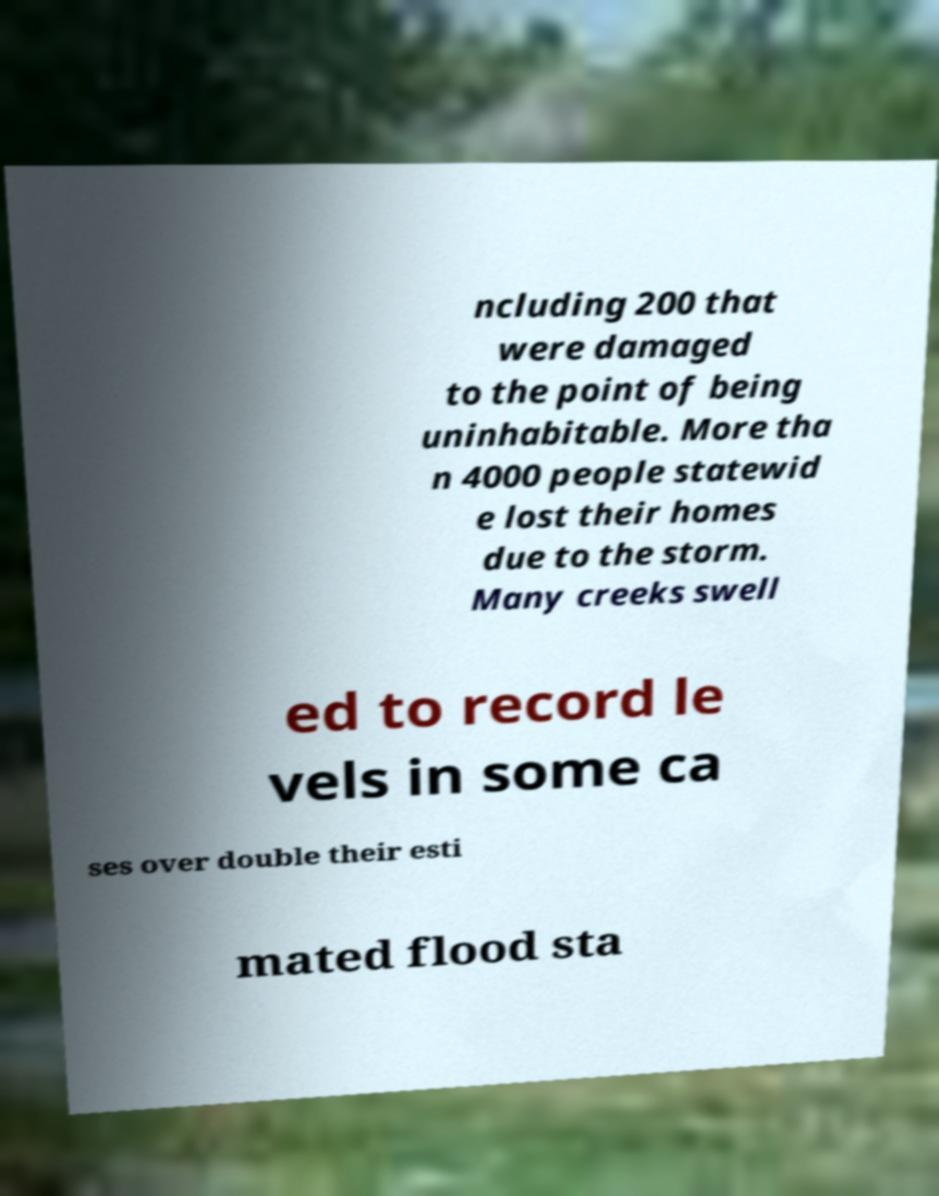For documentation purposes, I need the text within this image transcribed. Could you provide that? ncluding 200 that were damaged to the point of being uninhabitable. More tha n 4000 people statewid e lost their homes due to the storm. Many creeks swell ed to record le vels in some ca ses over double their esti mated flood sta 